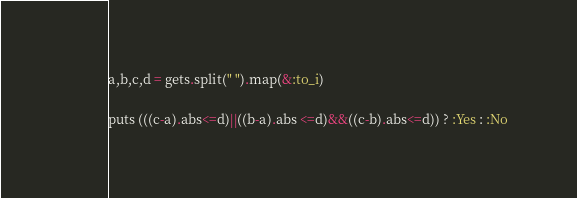Convert code to text. <code><loc_0><loc_0><loc_500><loc_500><_Ruby_>a,b,c,d = gets.split(" ").map(&:to_i)

puts (((c-a).abs<=d)||((b-a).abs <=d)&&((c-b).abs<=d)) ? :Yes : :No</code> 